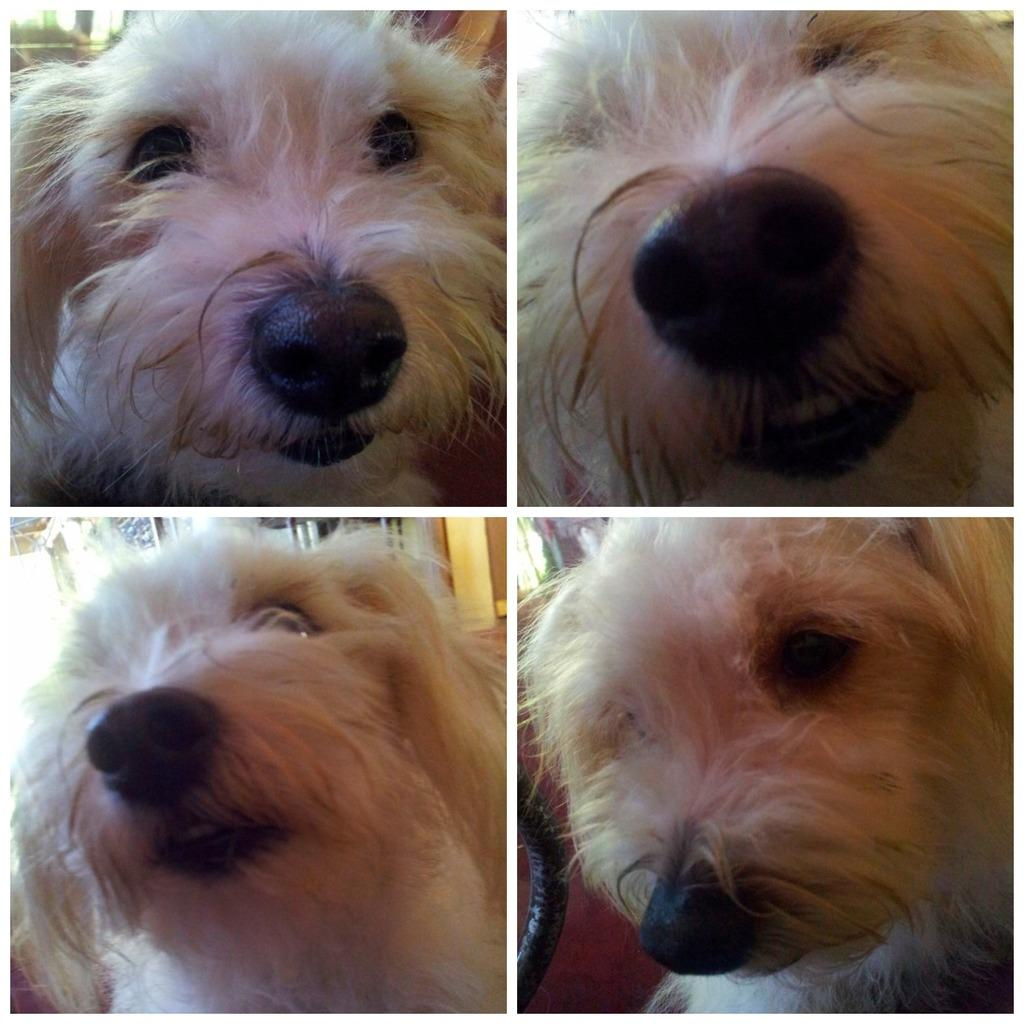What type of artwork is the image? The image is a collage. What animal is present in the collage? There is a dog in the image. What colors can be seen on the dog? The dog has black, brown, and white colors. What type of chalk is the dog using to draw in the image? There is no chalk or drawing activity present in the image; it features a dog in a collage. How can the oven be used to help the dog in the image? There is no oven present in the image, and the dog does not require any assistance. 